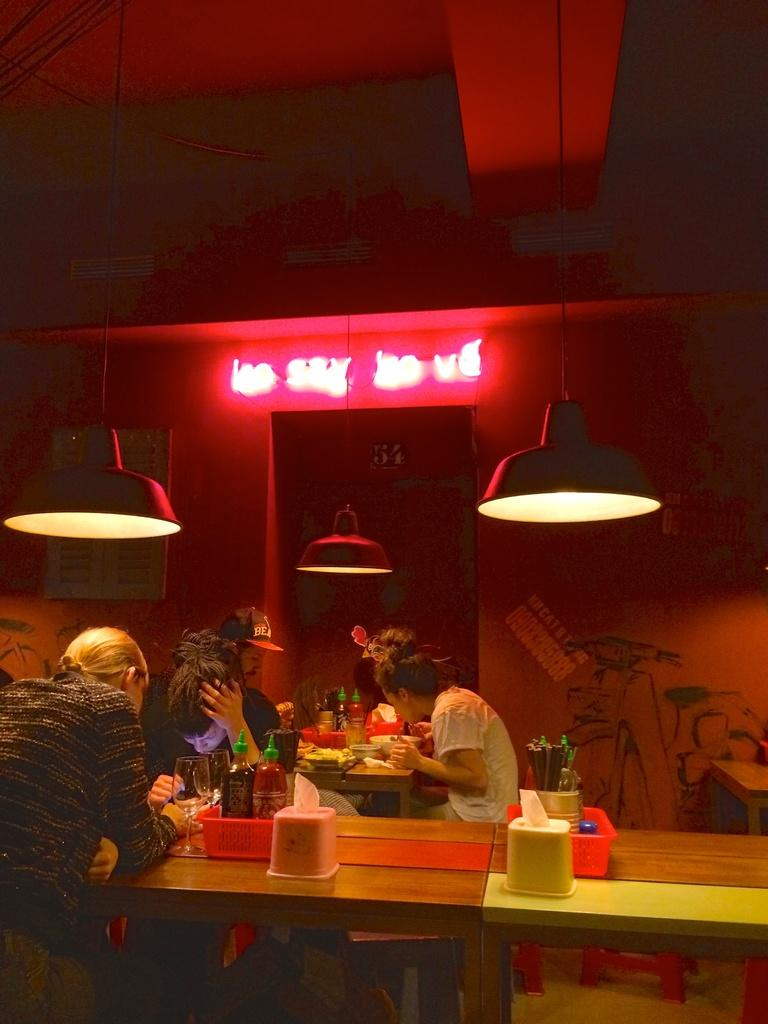How many people are in the image? There is a group of persons in the image, but the exact number is not specified. What are the persons in the image doing? The group of persons are having food and drinks. What type of fang can be seen in the image? There is no fang present in the image. What type of clouds can be seen in the image? The facts do not mention any clouds in the image. 